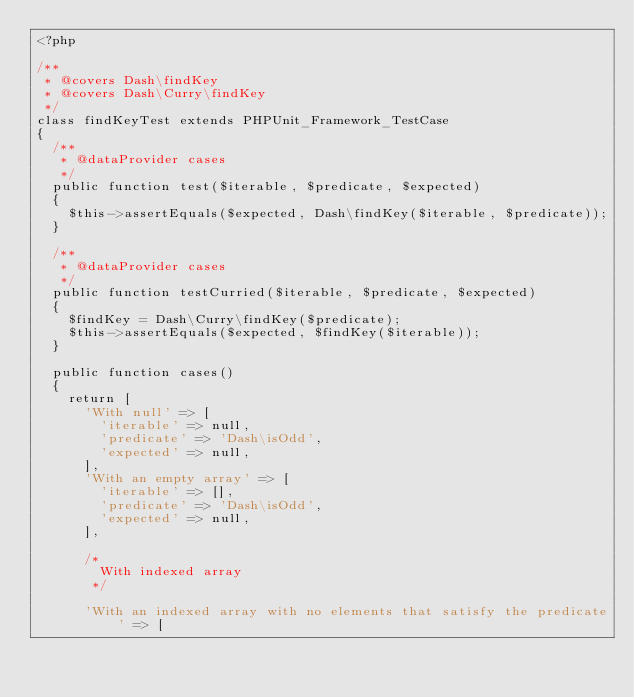<code> <loc_0><loc_0><loc_500><loc_500><_PHP_><?php

/**
 * @covers Dash\findKey
 * @covers Dash\Curry\findKey
 */
class findKeyTest extends PHPUnit_Framework_TestCase
{
	/**
	 * @dataProvider cases
	 */
	public function test($iterable, $predicate, $expected)
	{
		$this->assertEquals($expected, Dash\findKey($iterable, $predicate));
	}

	/**
	 * @dataProvider cases
	 */
	public function testCurried($iterable, $predicate, $expected)
	{
		$findKey = Dash\Curry\findKey($predicate);
		$this->assertEquals($expected, $findKey($iterable));
	}

	public function cases()
	{
		return [
			'With null' => [
				'iterable' => null,
				'predicate' => 'Dash\isOdd',
				'expected' => null,
			],
			'With an empty array' => [
				'iterable' => [],
				'predicate' => 'Dash\isOdd',
				'expected' => null,
			],

			/*
				With indexed array
			 */

			'With an indexed array with no elements that satisfy the predicate' => [</code> 